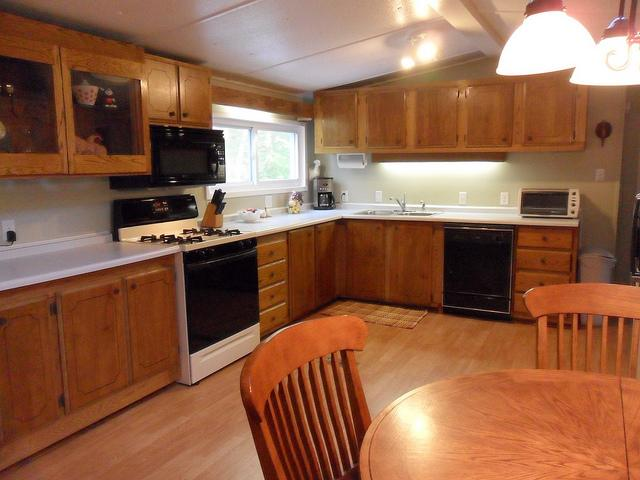What is the silver appliance near the window used to make? Please explain your reasoning. coffee. There is a glass kettle in the appliance. 